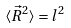Convert formula to latex. <formula><loc_0><loc_0><loc_500><loc_500>\langle \vec { R } ^ { 2 } \rangle = l ^ { 2 }</formula> 